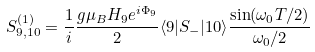<formula> <loc_0><loc_0><loc_500><loc_500>S _ { 9 , 1 0 } ^ { ( 1 ) } = \frac { 1 } { i } \frac { g \mu _ { B } H _ { 9 } e ^ { i \Phi _ { 9 } } } { 2 } \langle 9 | S _ { - } | 1 0 \rangle \frac { \sin ( \omega _ { 0 } T / 2 ) } { \omega _ { 0 } / 2 }</formula> 